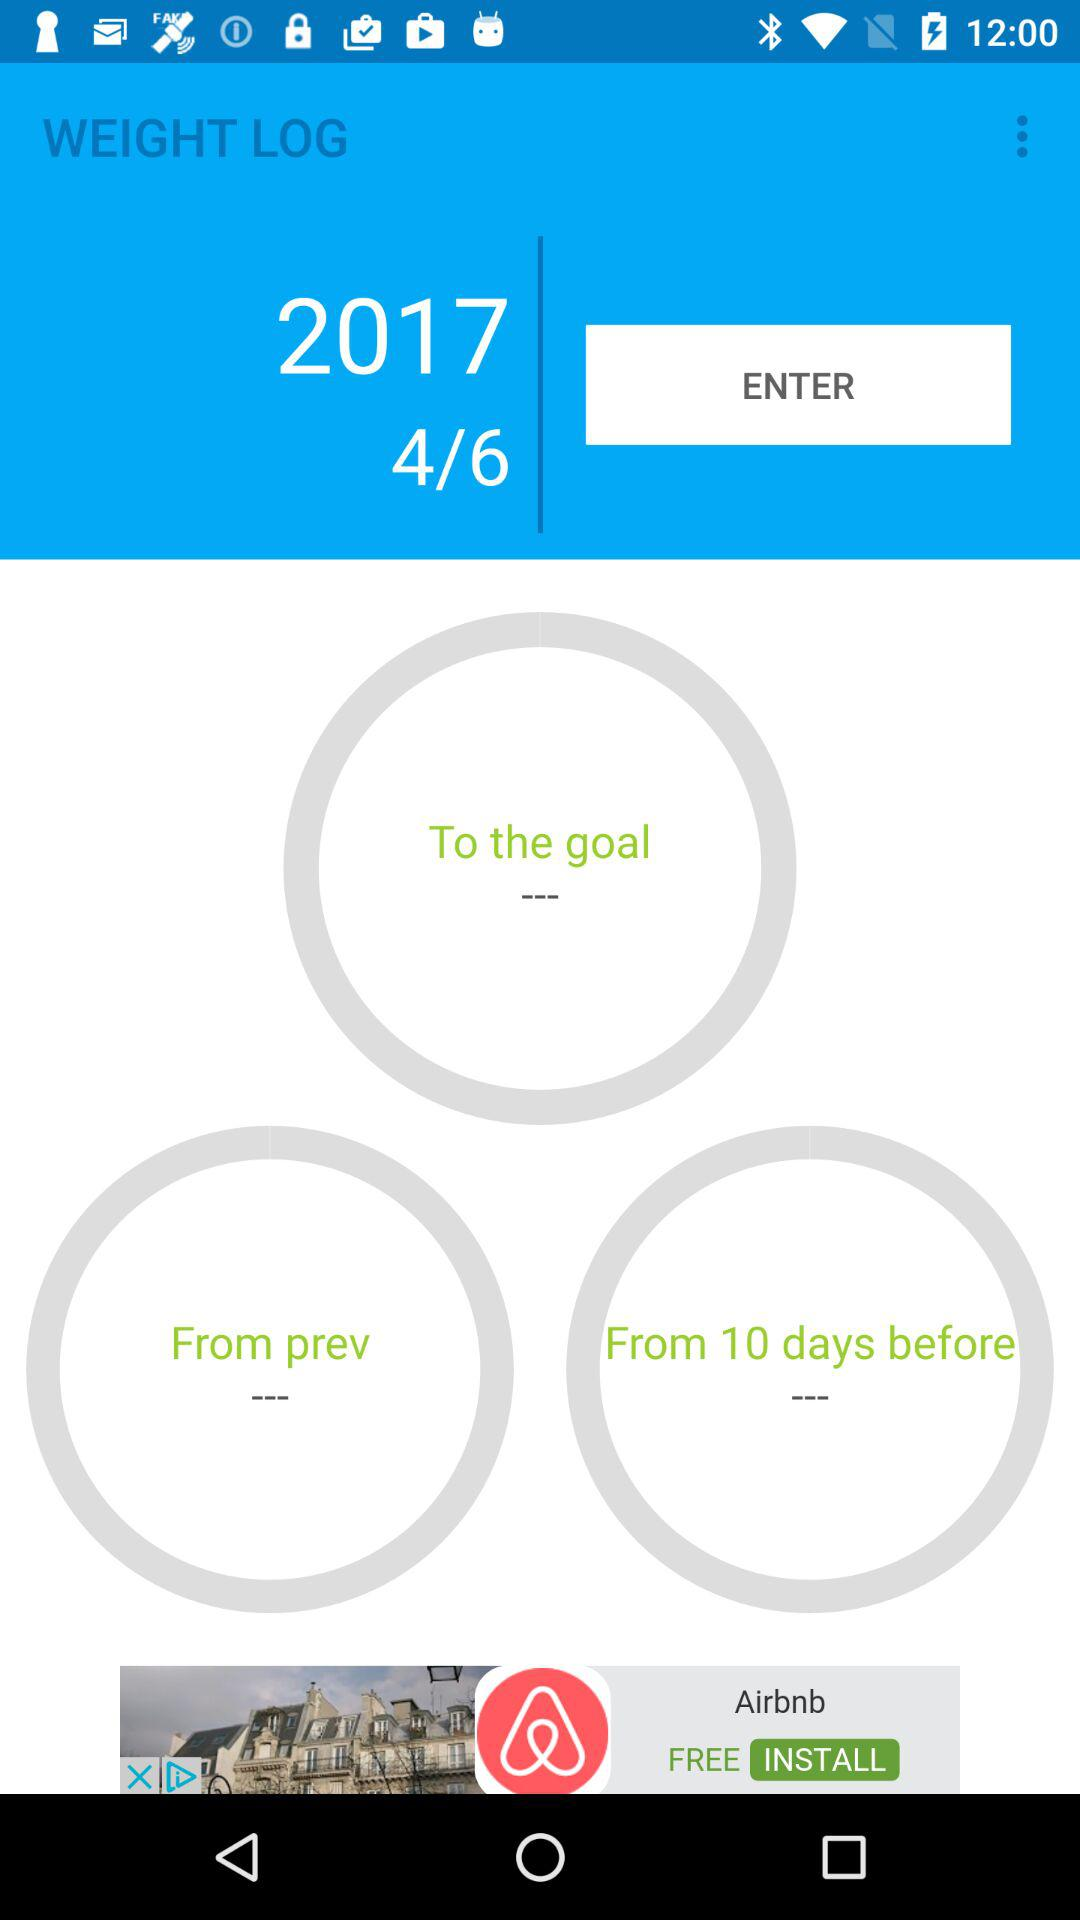Which log is open? The open log is "WEIGHT LOG". 